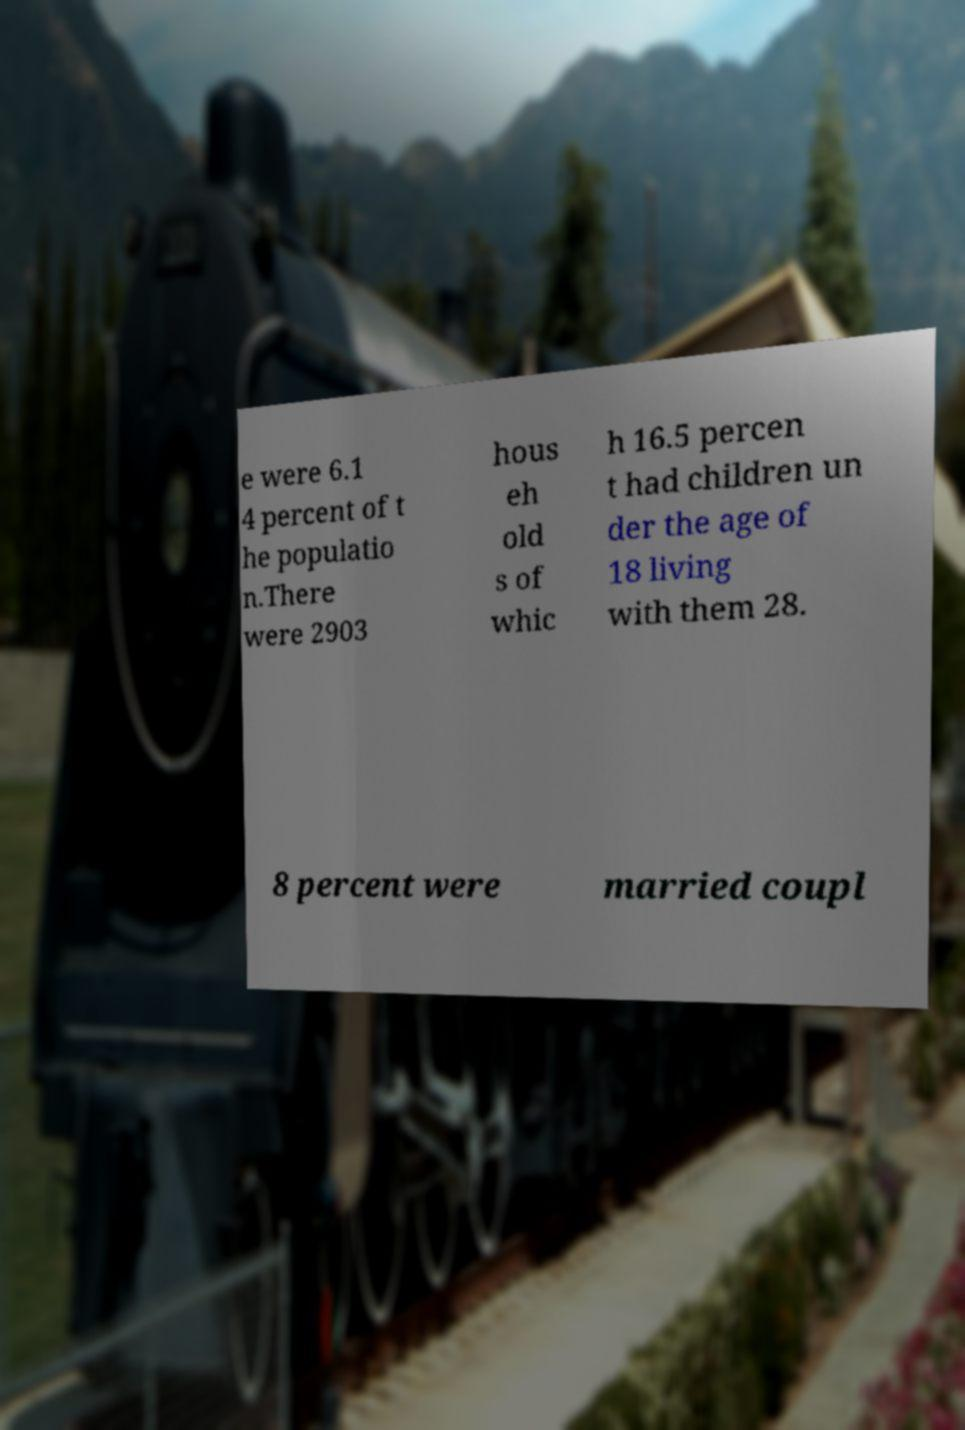I need the written content from this picture converted into text. Can you do that? e were 6.1 4 percent of t he populatio n.There were 2903 hous eh old s of whic h 16.5 percen t had children un der the age of 18 living with them 28. 8 percent were married coupl 